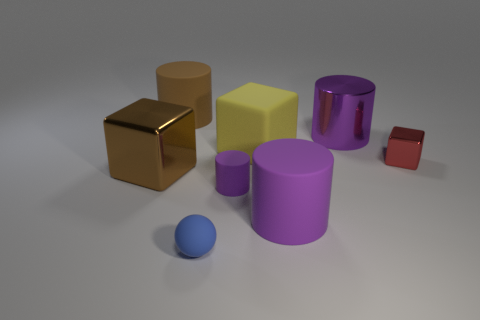Subtract all small blocks. How many blocks are left? 2 Subtract 1 balls. How many balls are left? 0 Subtract all brown cylinders. How many cylinders are left? 3 Add 1 purple metallic cylinders. How many objects exist? 9 Subtract all blocks. How many objects are left? 5 Subtract all gray cylinders. Subtract all cyan balls. How many cylinders are left? 4 Subtract all purple cylinders. How many brown balls are left? 0 Subtract all red shiny objects. Subtract all shiny cylinders. How many objects are left? 6 Add 5 big purple metal cylinders. How many big purple metal cylinders are left? 6 Add 2 large gray matte objects. How many large gray matte objects exist? 2 